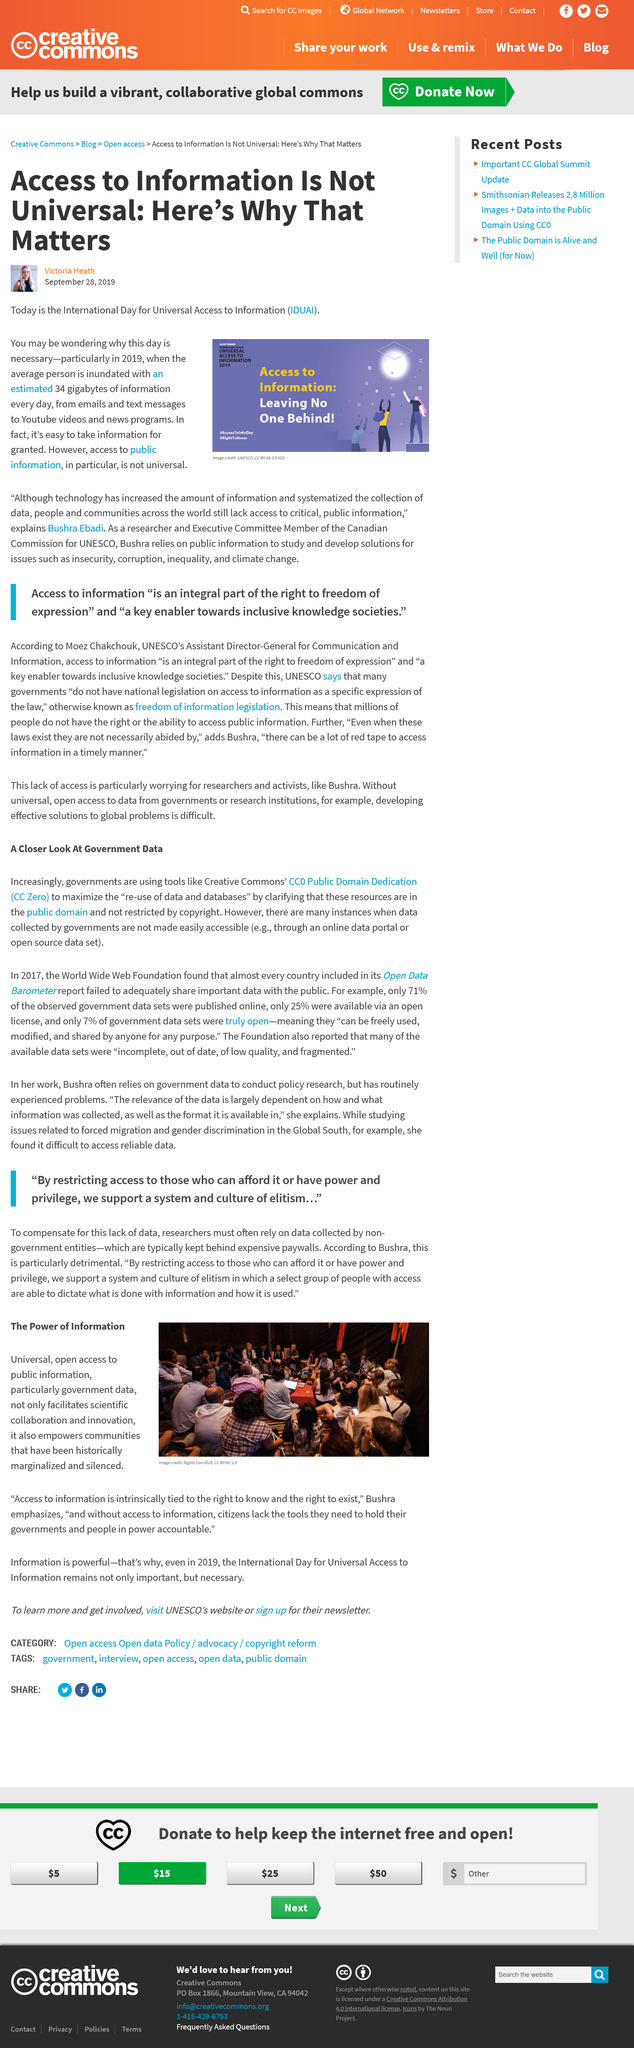Identify some key points in this picture. On the International Day for Universal Access to Information, we recognize the importance of access to information as a fundamental human right, and we call for all individuals to have equal access to information regardless of where they live or their circumstances. Communities throughout history have consistently been marginalized and silenced, often leading to their demise. Government data is provided as an example of public information. The image used for the Access to Information is sourced from UNESCO. Communities are empowered by open access information, as they are able to make informed decisions and take control of their own information. 